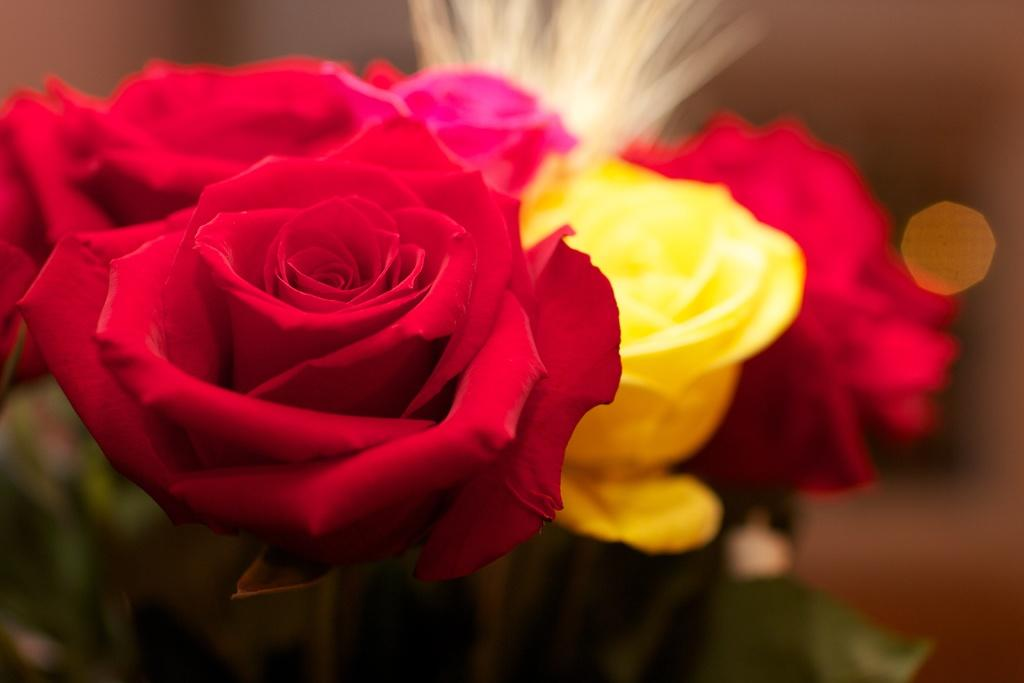What is present in the image? There are flowers in the image. Can you describe the background of the image? The background of the image is blurry. Where is the crown placed in the image? There is no crown present in the image; it only features flowers. 